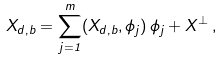<formula> <loc_0><loc_0><loc_500><loc_500>X _ { d , b } = \sum _ { j = 1 } ^ { m } ( X _ { d , b } , \phi _ { j } ) \, \phi _ { j } + X ^ { \perp } \, ,</formula> 